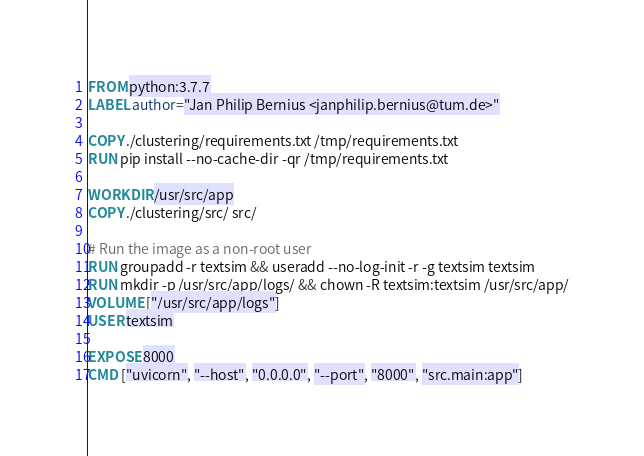Convert code to text. <code><loc_0><loc_0><loc_500><loc_500><_Dockerfile_>FROM python:3.7.7
LABEL author="Jan Philip Bernius <janphilip.bernius@tum.de>"

COPY ./clustering/requirements.txt /tmp/requirements.txt
RUN pip install --no-cache-dir -qr /tmp/requirements.txt

WORKDIR /usr/src/app
COPY ./clustering/src/ src/

# Run the image as a non-root user
RUN groupadd -r textsim && useradd --no-log-init -r -g textsim textsim
RUN mkdir -p /usr/src/app/logs/ && chown -R textsim:textsim /usr/src/app/
VOLUME ["/usr/src/app/logs"]
USER textsim

EXPOSE 8000
CMD ["uvicorn", "--host", "0.0.0.0", "--port", "8000", "src.main:app"]
</code> 